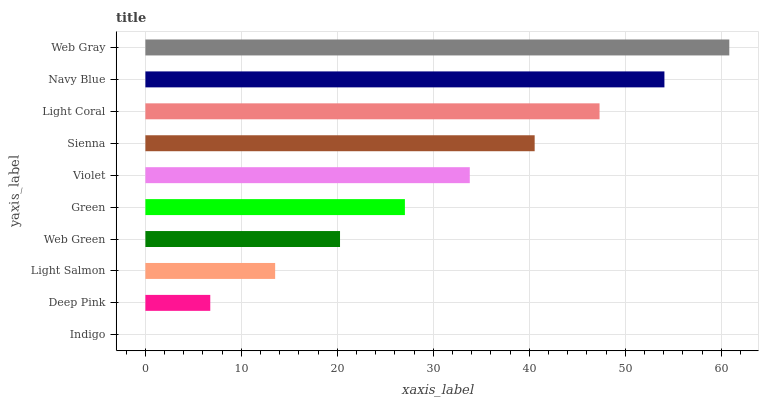Is Indigo the minimum?
Answer yes or no. Yes. Is Web Gray the maximum?
Answer yes or no. Yes. Is Deep Pink the minimum?
Answer yes or no. No. Is Deep Pink the maximum?
Answer yes or no. No. Is Deep Pink greater than Indigo?
Answer yes or no. Yes. Is Indigo less than Deep Pink?
Answer yes or no. Yes. Is Indigo greater than Deep Pink?
Answer yes or no. No. Is Deep Pink less than Indigo?
Answer yes or no. No. Is Violet the high median?
Answer yes or no. Yes. Is Green the low median?
Answer yes or no. Yes. Is Deep Pink the high median?
Answer yes or no. No. Is Violet the low median?
Answer yes or no. No. 